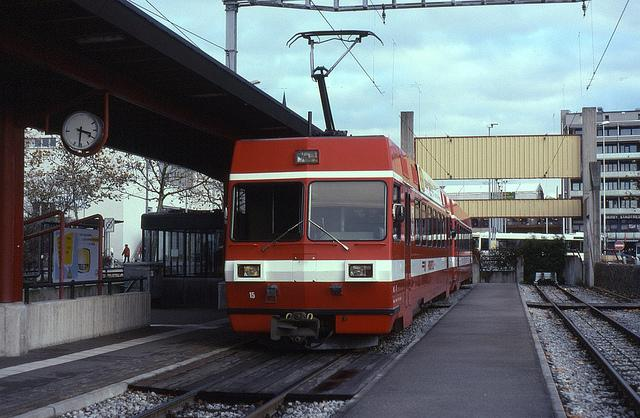How many hours until midnight?

Choices:
A) two
B) three
C) four
D) eight eight 